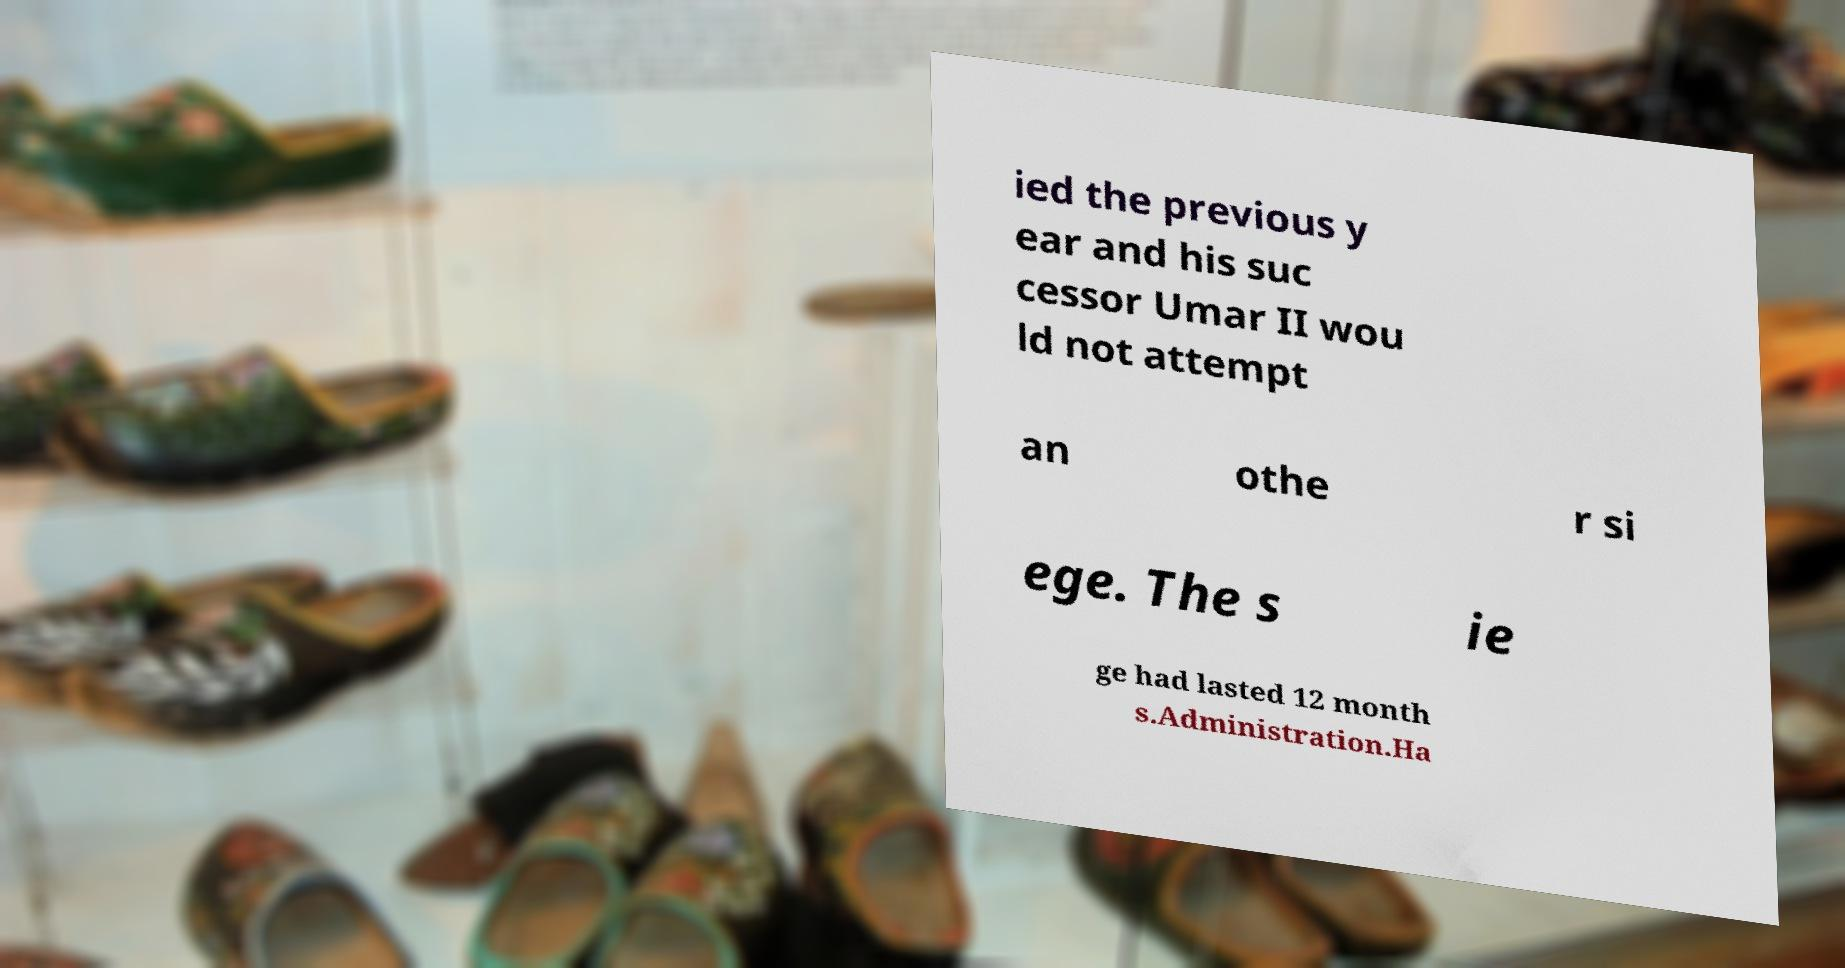There's text embedded in this image that I need extracted. Can you transcribe it verbatim? ied the previous y ear and his suc cessor Umar II wou ld not attempt an othe r si ege. The s ie ge had lasted 12 month s.Administration.Ha 